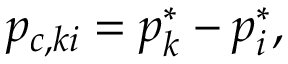Convert formula to latex. <formula><loc_0><loc_0><loc_500><loc_500>p _ { c , k i } = p _ { k } ^ { * } - p _ { i } ^ { * } ,</formula> 